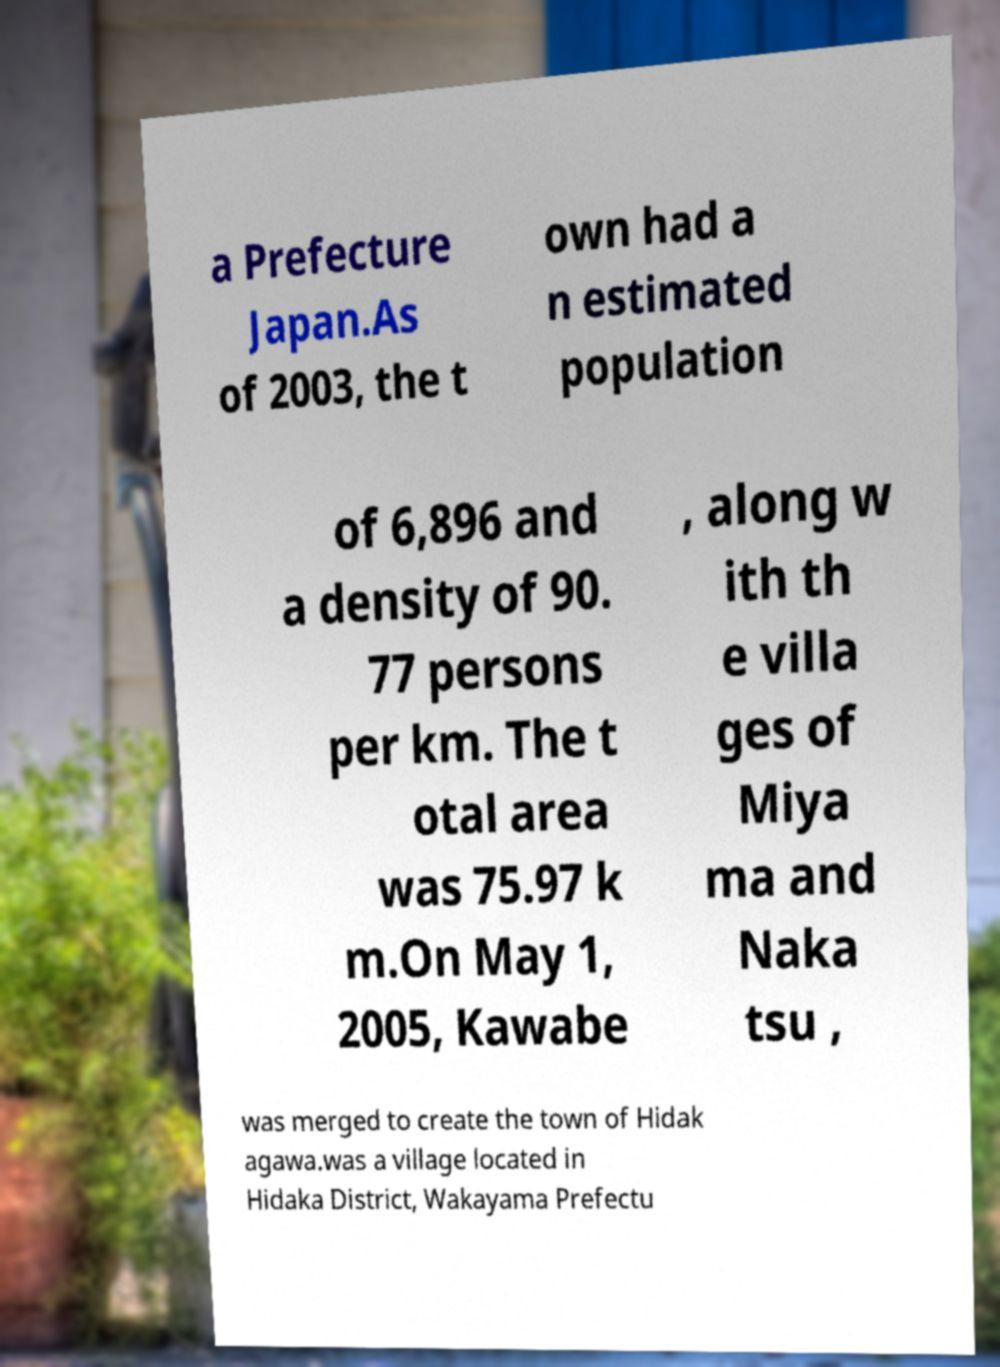Could you extract and type out the text from this image? a Prefecture Japan.As of 2003, the t own had a n estimated population of 6,896 and a density of 90. 77 persons per km. The t otal area was 75.97 k m.On May 1, 2005, Kawabe , along w ith th e villa ges of Miya ma and Naka tsu , was merged to create the town of Hidak agawa.was a village located in Hidaka District, Wakayama Prefectu 